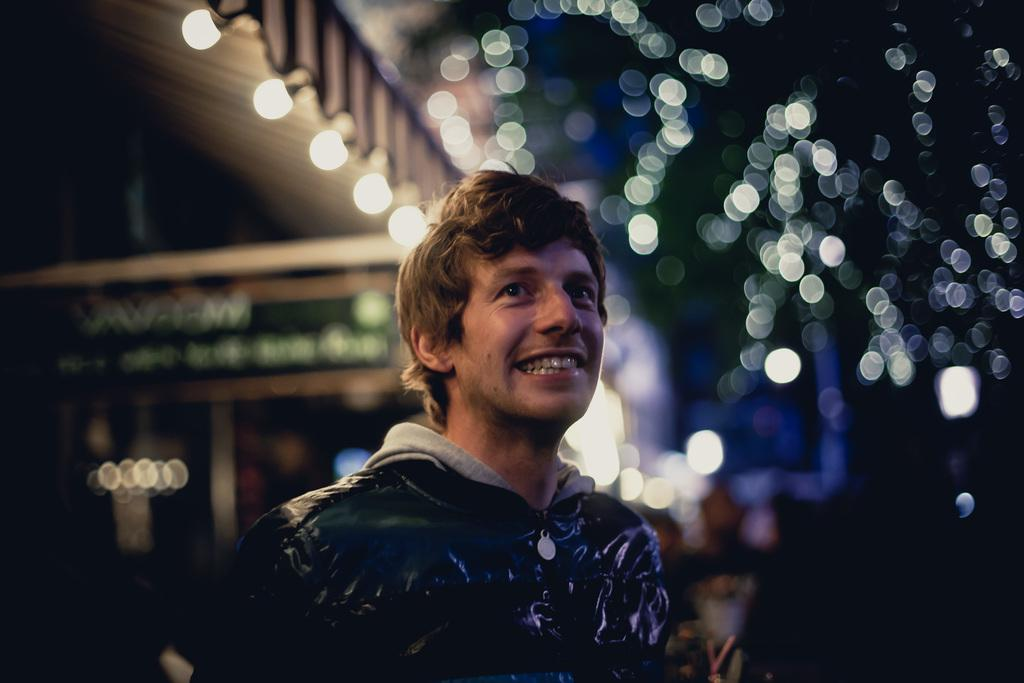What is the person in the image wearing? The person is wearing a black dress in the image. What is the facial expression of the person? The person is smiling in the image. What can be seen in the background of the image? Many lights are visible in the background of the image. What type of cast can be seen on the person's arm in the image? There is no cast visible on the person's arm in the image. What mark is present on the person's forehead in the image? There is no mark visible on the person's forehead in the image. 